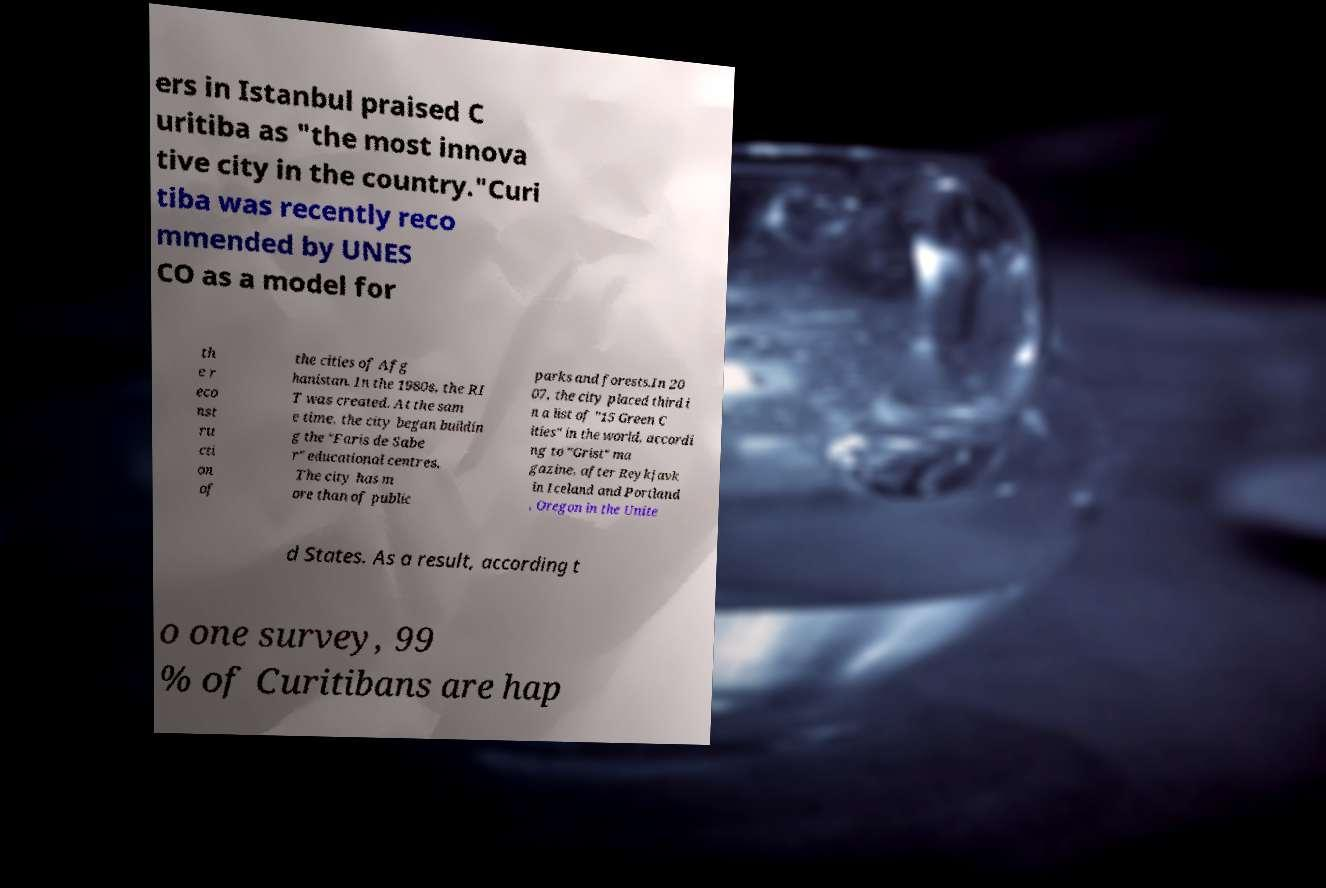I need the written content from this picture converted into text. Can you do that? ers in Istanbul praised C uritiba as "the most innova tive city in the country."Curi tiba was recently reco mmended by UNES CO as a model for th e r eco nst ru cti on of the cities of Afg hanistan. In the 1980s, the RI T was created. At the sam e time, the city began buildin g the "Faris de Sabe r" educational centres. The city has m ore than of public parks and forests.In 20 07, the city placed third i n a list of "15 Green C ities" in the world, accordi ng to "Grist" ma gazine, after Reykjavk in Iceland and Portland , Oregon in the Unite d States. As a result, according t o one survey, 99 % of Curitibans are hap 